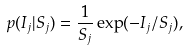<formula> <loc_0><loc_0><loc_500><loc_500>p ( I _ { j } | S _ { j } ) = \frac { 1 } { S _ { j } } \exp ( - I _ { j } / S _ { j } ) ,</formula> 